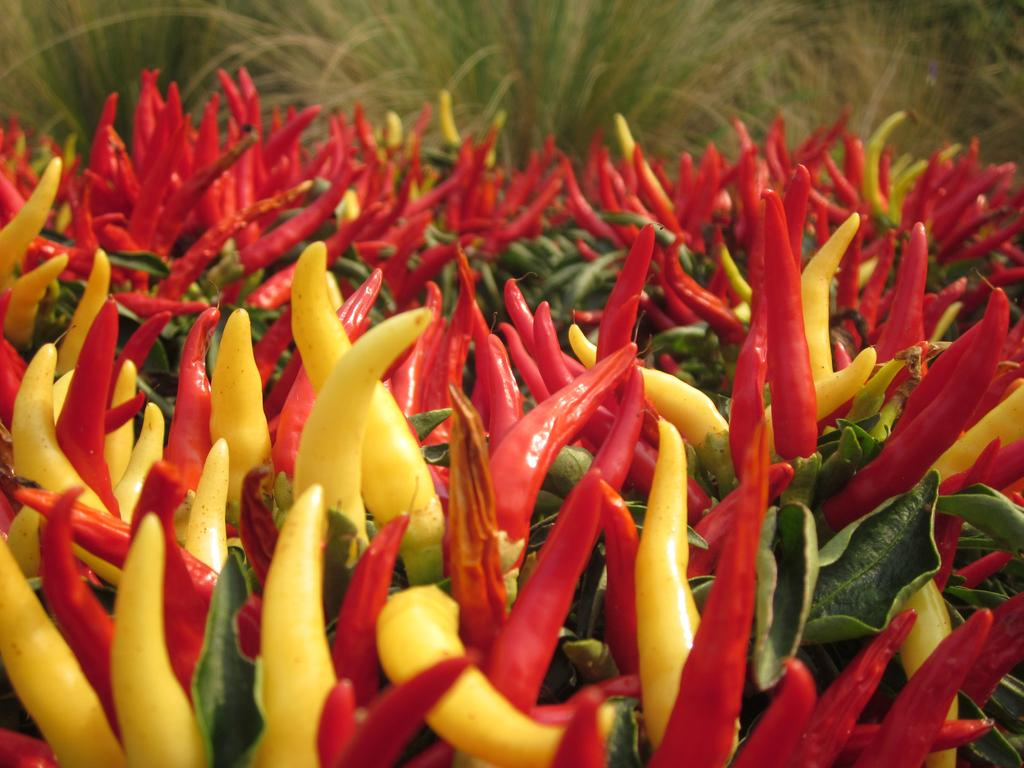What type of food items are present in the image? There are chilies in the image. Can you describe the colors of the chilies? The chilies are red and yellow in color. What other plant-related items can be seen in the image? There are leaves in the image. What is the color of the leaves? The leaves are green in color. What can be seen in the background of the image? There is grass visible in the background of the image. What type of pail is being used to attempt to break the chain in the image? There is no pail, attempt, or chain present in the image. 